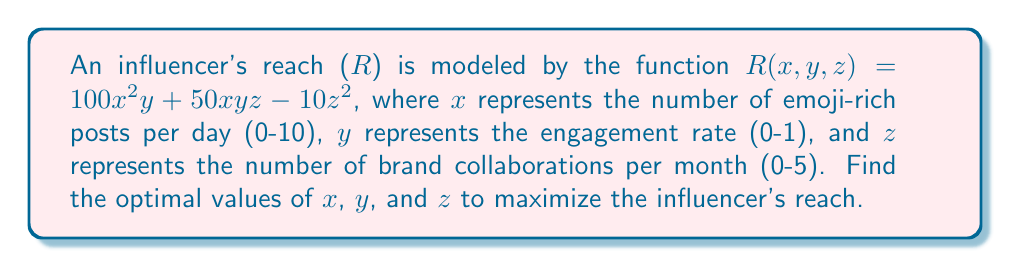Provide a solution to this math problem. To find the maximum reach, we need to find the critical points of the function $R(x, y, z)$ and evaluate them.

Step 1: Calculate partial derivatives
$$\frac{\partial R}{\partial x} = 200xy + 50yz$$
$$\frac{\partial R}{\partial y} = 100x^2 + 50xz$$
$$\frac{\partial R}{\partial z} = 50xy - 20z$$

Step 2: Set each partial derivative to zero and solve the system of equations
$$200xy + 50yz = 0 \quad (1)$$
$$100x^2 + 50xz = 0 \quad (2)$$
$$50xy - 20z = 0 \quad (3)$$

Step 3: From equation (3), we get:
$$z = \frac{5xy}{2} \quad (4)$$

Step 4: Substitute (4) into (2):
$$100x^2 + 50x(\frac{5xy}{2}) = 0$$
$$100x^2 + 125x^2y = 0$$
$$x^2(100 + 125y) = 0$$

This implies either $x = 0$ or $y = -\frac{4}{5}$. Since $y$ represents engagement rate and must be between 0 and 1, $y = -\frac{4}{5}$ is not valid. Therefore, $x = 0$.

Step 5: Substitute $x = 0$ into (4):
$$z = \frac{5 \cdot 0 \cdot y}{2} = 0$$

Step 6: The critical point is $(0, y, 0)$. However, this results in $R = 0$, which is clearly not the maximum reach.

Step 7: Since the maximum doesn't occur at a critical point, it must occur on the boundary of the domain. Let's evaluate $R$ at the extremes of each variable:

For $x = 10$, $y = 1$, $z = 5$:
$$R(10, 1, 5) = 100(10)^2(1) + 50(10)(1)(5) - 10(5)^2 = 10,000 + 2,500 - 250 = 12,250$$

This is the maximum value within the given constraints.
Answer: $(x, y, z) = (10, 1, 5)$; $R_{max} = 12,250$ 